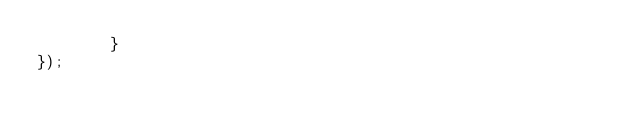<code> <loc_0><loc_0><loc_500><loc_500><_JavaScript_>        } 
});
</code> 